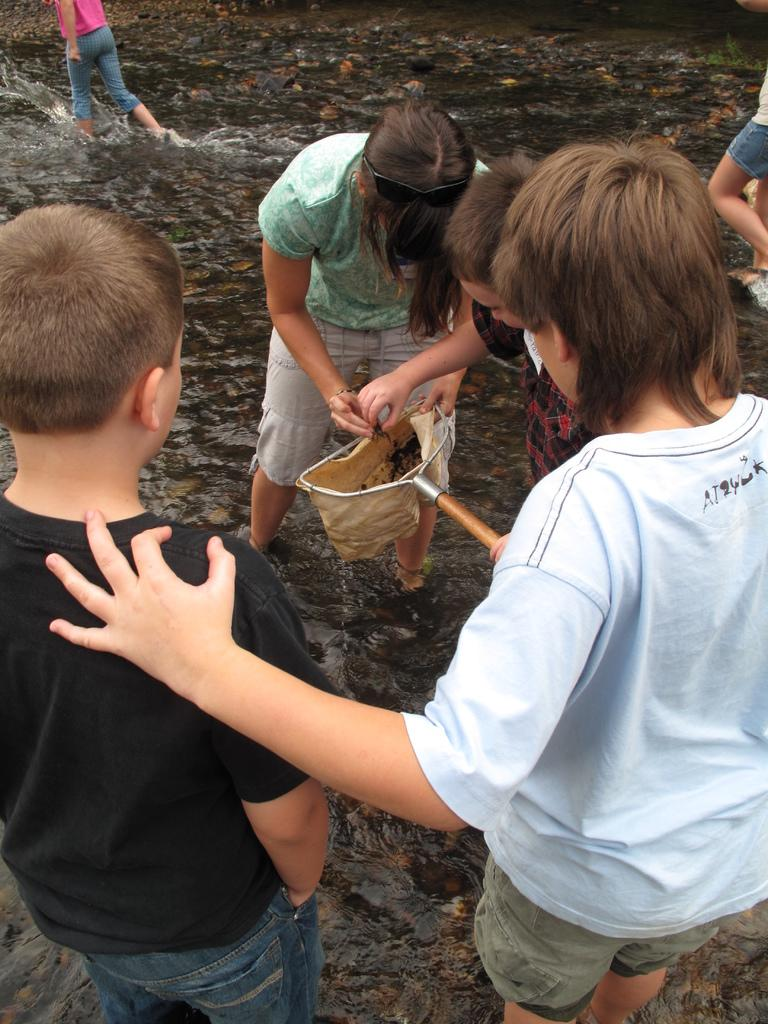What are the people in the foreground of the image doing? The people in the foreground of the image are doing some work. What material are they working with? They appear to be working with stones. Can you describe the person in the background of the image? There is a person in the background of the image, but no specific details are provided. What type of playground equipment can be seen in the image? There is no playground equipment present in the image. What color are the shoes worn by the person in the background? There is no information about the person's shoes in the background, as no shoes are visible in the image. 